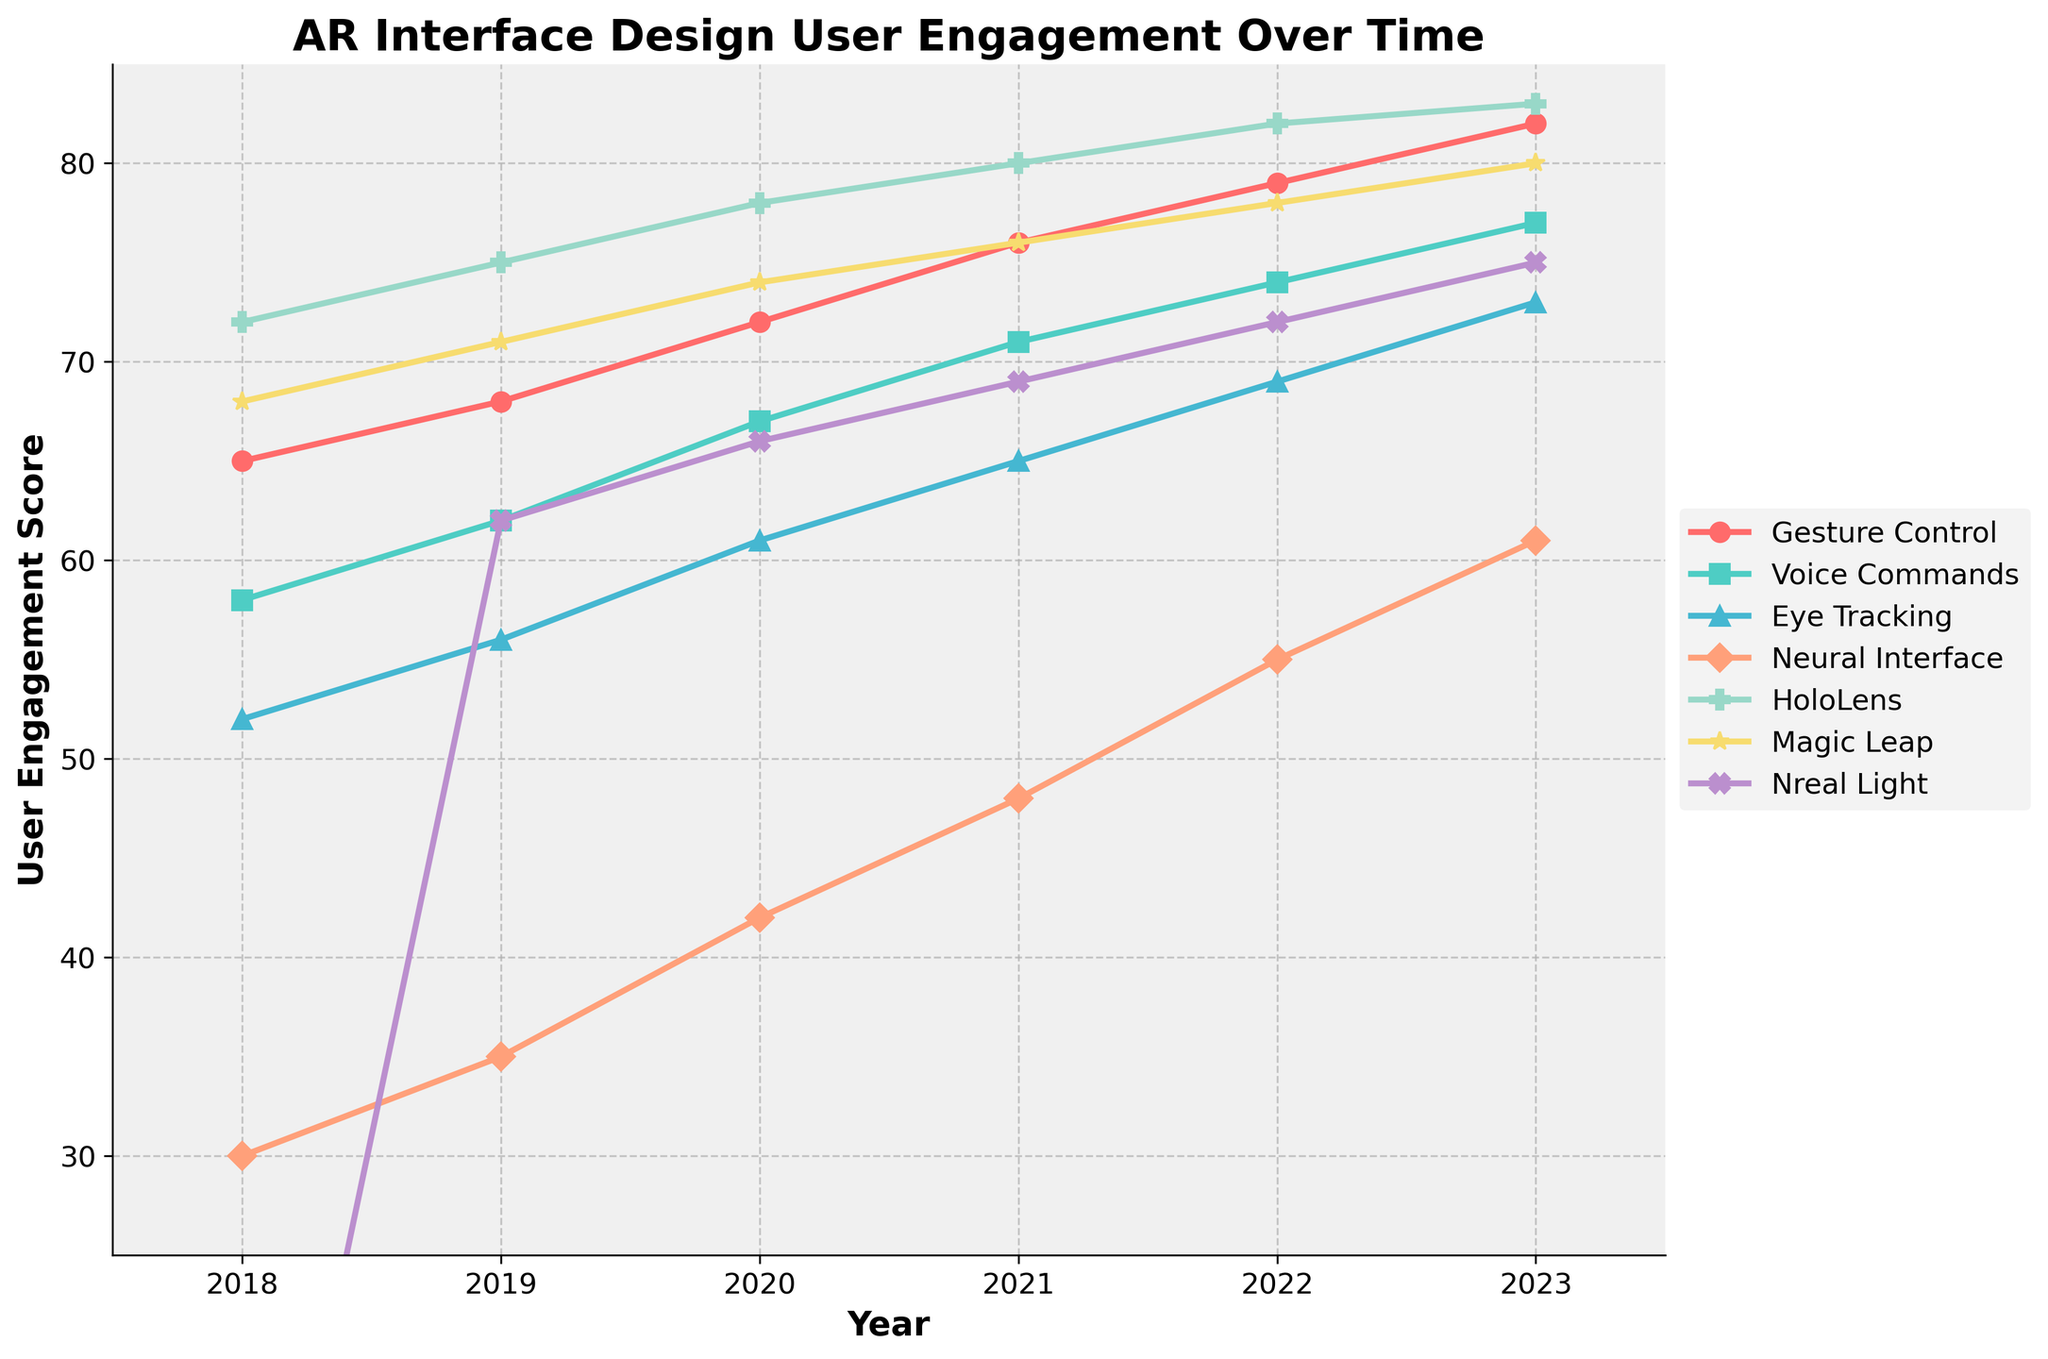How did the user engagement for Voice Commands change from 2018 to 2023? To determine this, locate the "Voice Commands" line on the chart and look at its values in 2018 and 2023. In 2018, it started at 58 and rose to 77 in 2023, resulting in an increase of 19 points.
Answer: Increased by 19 points Which AR interface design had the highest user engagement score in 2023? To find the highest score in 2023, look at the rightmost values of all the lines. The highest value among them is 83, which corresponds to "HoloLens".
Answer: HoloLens Compare the user engagement trends of Gesture Control and Neural Interface from 2018 to 2023. Gesture Control's user engagement increased from 65 in 2018 to 82 in 2023. Meanwhile, Neural Interface's engagement increased from 30 in 2018 to 61 in 2023. Both have upward trends, but Gesture Control consistently had higher values.
Answer: Both increased, Gesture Control has higher values What is the difference in user engagement scores between Eye Tracking and Nreal Light in 2021? Eye Tracking's score in 2021 is 65, and Nreal Light's score is 69. Subtracting 65 from 69 gives a difference of 4 points.
Answer: 4 points On average, how much did the user engagement score for Magic Leap increase annually between 2018 and 2023? Magic Leap's scores from 2018 to 2023 are 68, 71, 74, 76, 78, and 80. The annual increase can be calculated by [(80 - 68) / 5] = 2.4 per year.
Answer: 2.4 per year Which interface showed the most significant improvement in user engagement from 2018 to 2023? Calculate the difference between 2023 and 2018 for each interface. HoloLens went from 72 to 83, an increase of 11, which is the highest among all.
Answer: HoloLens What are the user engagement scores for Neural Interface and Magic Leap in 2020, and which is higher? Neural Interface and Magic Leap scores in 2020 are 42 and 74, respectively. Comparing these values, Magic Leap had a higher score.
Answer: Magic Leap Compare the visual trends of HoloLens and Eye Tracking from 2018 to 2023. HoloLens consistently increased linearly from 72 to 83 while Eye Tracking increased from 52 to 73. Both lines trend upwards, with HoloLens maintaining higher values throughout.
Answer: Both increased, HoloLens higher What is the combined user engagement score of all interfaces in 2022? Add up all the scores for 2022: 79 (Gesture Control) + 74 (Voice Commands) + 69 (Eye Tracking) + 55 (Neural Interface) + 82 (HoloLens) + 78 (Magic Leap) + 72 (Nreal Light) = 509.
Answer: 509 